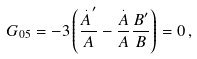<formula> <loc_0><loc_0><loc_500><loc_500>G _ { 0 5 } = - 3 \left ( \frac { \overset { . } { A } ^ { \prime } } { A } - \frac { \overset { . } { A } } { A } \frac { B ^ { \prime } } { B } \right ) = 0 \, ,</formula> 